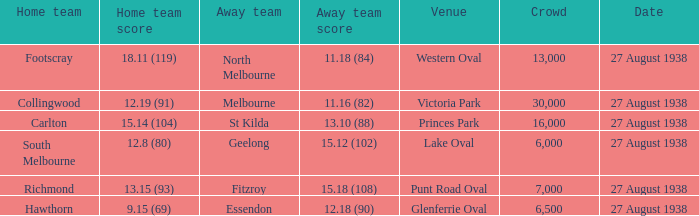18 (108)? 13.15 (93). 